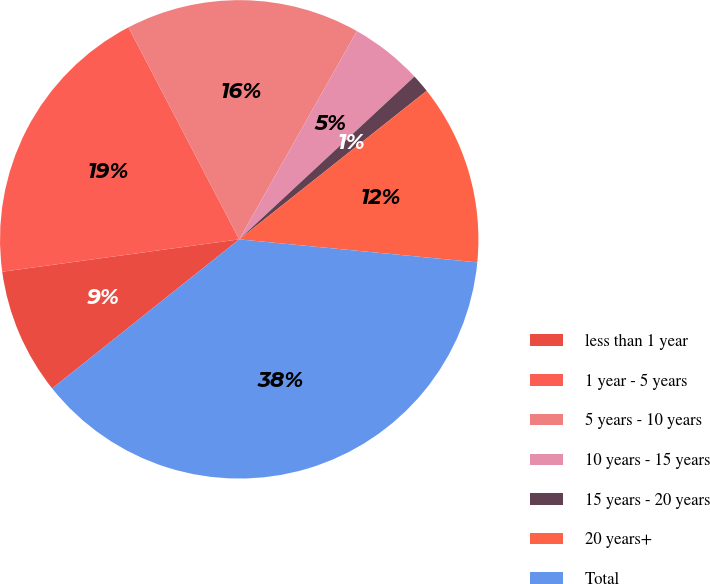Convert chart. <chart><loc_0><loc_0><loc_500><loc_500><pie_chart><fcel>less than 1 year<fcel>1 year - 5 years<fcel>5 years - 10 years<fcel>10 years - 15 years<fcel>15 years - 20 years<fcel>20 years+<fcel>Total<nl><fcel>8.55%<fcel>19.5%<fcel>15.85%<fcel>4.9%<fcel>1.25%<fcel>12.2%<fcel>37.76%<nl></chart> 